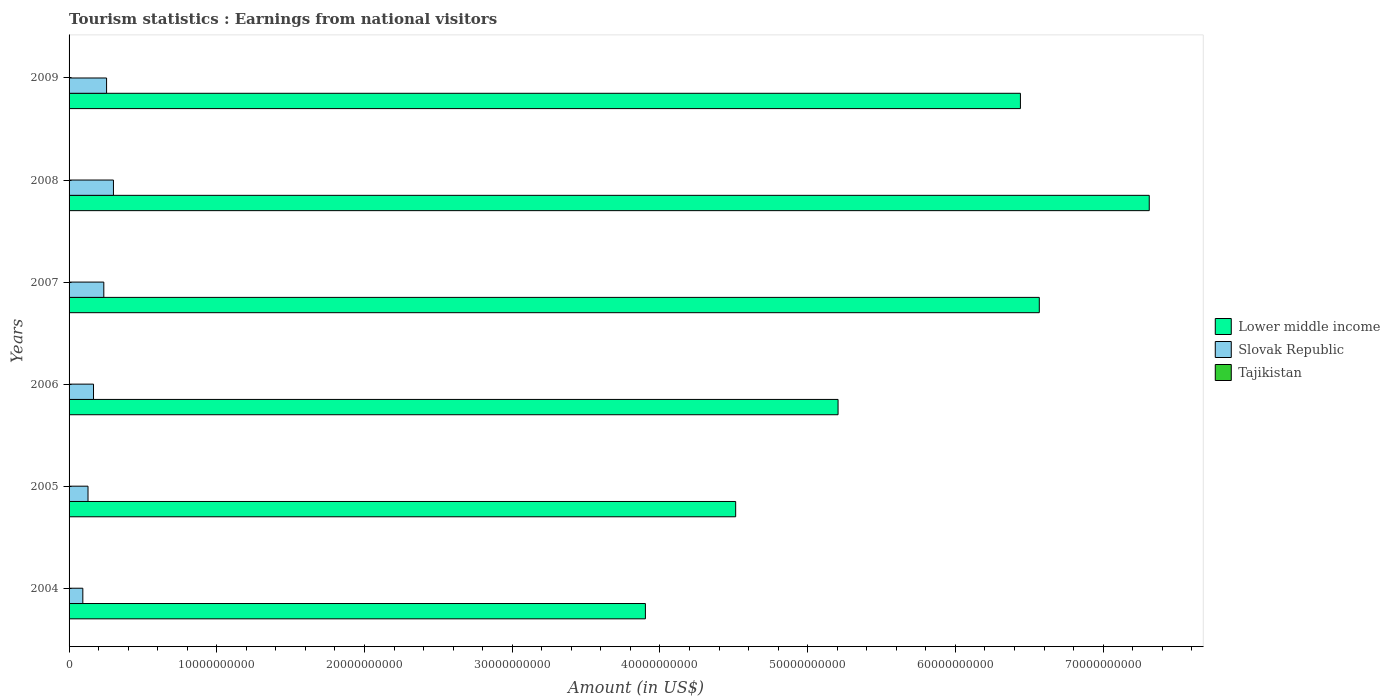How many different coloured bars are there?
Give a very brief answer. 3. How many groups of bars are there?
Provide a short and direct response. 6. Are the number of bars on each tick of the Y-axis equal?
Make the answer very short. Yes. How many bars are there on the 1st tick from the top?
Make the answer very short. 3. How many bars are there on the 2nd tick from the bottom?
Ensure brevity in your answer.  3. What is the label of the 4th group of bars from the top?
Make the answer very short. 2006. What is the earnings from national visitors in Tajikistan in 2009?
Your response must be concise. 1.95e+07. Across all years, what is the maximum earnings from national visitors in Lower middle income?
Provide a short and direct response. 7.31e+1. Across all years, what is the minimum earnings from national visitors in Tajikistan?
Offer a very short reply. 9.10e+06. In which year was the earnings from national visitors in Slovak Republic maximum?
Provide a short and direct response. 2008. What is the total earnings from national visitors in Tajikistan in the graph?
Ensure brevity in your answer.  8.96e+07. What is the difference between the earnings from national visitors in Lower middle income in 2004 and that in 2006?
Provide a short and direct response. -1.30e+1. What is the difference between the earnings from national visitors in Slovak Republic in 2009 and the earnings from national visitors in Tajikistan in 2007?
Provide a succinct answer. 2.52e+09. What is the average earnings from national visitors in Tajikistan per year?
Give a very brief answer. 1.49e+07. In the year 2008, what is the difference between the earnings from national visitors in Slovak Republic and earnings from national visitors in Lower middle income?
Make the answer very short. -7.01e+1. What is the ratio of the earnings from national visitors in Tajikistan in 2007 to that in 2009?
Provide a succinct answer. 0.85. What is the difference between the highest and the second highest earnings from national visitors in Lower middle income?
Provide a short and direct response. 7.44e+09. What is the difference between the highest and the lowest earnings from national visitors in Slovak Republic?
Provide a succinct answer. 2.07e+09. Is the sum of the earnings from national visitors in Lower middle income in 2005 and 2009 greater than the maximum earnings from national visitors in Tajikistan across all years?
Your answer should be compact. Yes. What does the 3rd bar from the top in 2005 represents?
Provide a succinct answer. Lower middle income. What does the 3rd bar from the bottom in 2007 represents?
Give a very brief answer. Tajikistan. Is it the case that in every year, the sum of the earnings from national visitors in Slovak Republic and earnings from national visitors in Lower middle income is greater than the earnings from national visitors in Tajikistan?
Make the answer very short. Yes. How many bars are there?
Ensure brevity in your answer.  18. What is the difference between two consecutive major ticks on the X-axis?
Your response must be concise. 1.00e+1. Are the values on the major ticks of X-axis written in scientific E-notation?
Your response must be concise. No. How many legend labels are there?
Your response must be concise. 3. How are the legend labels stacked?
Offer a terse response. Vertical. What is the title of the graph?
Offer a terse response. Tourism statistics : Earnings from national visitors. Does "Nigeria" appear as one of the legend labels in the graph?
Ensure brevity in your answer.  No. What is the Amount (in US$) in Lower middle income in 2004?
Ensure brevity in your answer.  3.90e+1. What is the Amount (in US$) of Slovak Republic in 2004?
Offer a terse response. 9.31e+08. What is the Amount (in US$) of Tajikistan in 2004?
Give a very brief answer. 9.60e+06. What is the Amount (in US$) in Lower middle income in 2005?
Make the answer very short. 4.51e+1. What is the Amount (in US$) of Slovak Republic in 2005?
Keep it short and to the point. 1.28e+09. What is the Amount (in US$) of Tajikistan in 2005?
Your answer should be very brief. 9.10e+06. What is the Amount (in US$) in Lower middle income in 2006?
Make the answer very short. 5.21e+1. What is the Amount (in US$) in Slovak Republic in 2006?
Your response must be concise. 1.66e+09. What is the Amount (in US$) of Tajikistan in 2006?
Your response must be concise. 1.12e+07. What is the Amount (in US$) of Lower middle income in 2007?
Ensure brevity in your answer.  6.57e+1. What is the Amount (in US$) in Slovak Republic in 2007?
Your answer should be compact. 2.35e+09. What is the Amount (in US$) in Tajikistan in 2007?
Keep it short and to the point. 1.65e+07. What is the Amount (in US$) of Lower middle income in 2008?
Keep it short and to the point. 7.31e+1. What is the Amount (in US$) of Slovak Republic in 2008?
Offer a terse response. 3.00e+09. What is the Amount (in US$) of Tajikistan in 2008?
Your response must be concise. 2.37e+07. What is the Amount (in US$) in Lower middle income in 2009?
Provide a short and direct response. 6.44e+1. What is the Amount (in US$) in Slovak Republic in 2009?
Give a very brief answer. 2.54e+09. What is the Amount (in US$) of Tajikistan in 2009?
Your response must be concise. 1.95e+07. Across all years, what is the maximum Amount (in US$) of Lower middle income?
Offer a very short reply. 7.31e+1. Across all years, what is the maximum Amount (in US$) of Slovak Republic?
Your response must be concise. 3.00e+09. Across all years, what is the maximum Amount (in US$) in Tajikistan?
Keep it short and to the point. 2.37e+07. Across all years, what is the minimum Amount (in US$) in Lower middle income?
Give a very brief answer. 3.90e+1. Across all years, what is the minimum Amount (in US$) of Slovak Republic?
Offer a very short reply. 9.31e+08. Across all years, what is the minimum Amount (in US$) in Tajikistan?
Give a very brief answer. 9.10e+06. What is the total Amount (in US$) of Lower middle income in the graph?
Your response must be concise. 3.39e+11. What is the total Amount (in US$) in Slovak Republic in the graph?
Provide a short and direct response. 1.18e+1. What is the total Amount (in US$) in Tajikistan in the graph?
Your response must be concise. 8.96e+07. What is the difference between the Amount (in US$) of Lower middle income in 2004 and that in 2005?
Offer a very short reply. -6.11e+09. What is the difference between the Amount (in US$) in Slovak Republic in 2004 and that in 2005?
Provide a succinct answer. -3.51e+08. What is the difference between the Amount (in US$) of Lower middle income in 2004 and that in 2006?
Offer a very short reply. -1.30e+1. What is the difference between the Amount (in US$) of Slovak Republic in 2004 and that in 2006?
Offer a very short reply. -7.24e+08. What is the difference between the Amount (in US$) of Tajikistan in 2004 and that in 2006?
Make the answer very short. -1.60e+06. What is the difference between the Amount (in US$) of Lower middle income in 2004 and that in 2007?
Keep it short and to the point. -2.67e+1. What is the difference between the Amount (in US$) in Slovak Republic in 2004 and that in 2007?
Your answer should be compact. -1.42e+09. What is the difference between the Amount (in US$) of Tajikistan in 2004 and that in 2007?
Your answer should be compact. -6.90e+06. What is the difference between the Amount (in US$) of Lower middle income in 2004 and that in 2008?
Ensure brevity in your answer.  -3.41e+1. What is the difference between the Amount (in US$) of Slovak Republic in 2004 and that in 2008?
Ensure brevity in your answer.  -2.07e+09. What is the difference between the Amount (in US$) of Tajikistan in 2004 and that in 2008?
Your answer should be very brief. -1.41e+07. What is the difference between the Amount (in US$) in Lower middle income in 2004 and that in 2009?
Make the answer very short. -2.54e+1. What is the difference between the Amount (in US$) of Slovak Republic in 2004 and that in 2009?
Offer a very short reply. -1.61e+09. What is the difference between the Amount (in US$) in Tajikistan in 2004 and that in 2009?
Keep it short and to the point. -9.90e+06. What is the difference between the Amount (in US$) in Lower middle income in 2005 and that in 2006?
Provide a succinct answer. -6.93e+09. What is the difference between the Amount (in US$) in Slovak Republic in 2005 and that in 2006?
Provide a short and direct response. -3.73e+08. What is the difference between the Amount (in US$) of Tajikistan in 2005 and that in 2006?
Keep it short and to the point. -2.10e+06. What is the difference between the Amount (in US$) in Lower middle income in 2005 and that in 2007?
Offer a terse response. -2.06e+1. What is the difference between the Amount (in US$) in Slovak Republic in 2005 and that in 2007?
Provide a short and direct response. -1.07e+09. What is the difference between the Amount (in US$) of Tajikistan in 2005 and that in 2007?
Offer a terse response. -7.40e+06. What is the difference between the Amount (in US$) of Lower middle income in 2005 and that in 2008?
Give a very brief answer. -2.80e+1. What is the difference between the Amount (in US$) in Slovak Republic in 2005 and that in 2008?
Offer a very short reply. -1.72e+09. What is the difference between the Amount (in US$) of Tajikistan in 2005 and that in 2008?
Ensure brevity in your answer.  -1.46e+07. What is the difference between the Amount (in US$) of Lower middle income in 2005 and that in 2009?
Offer a terse response. -1.93e+1. What is the difference between the Amount (in US$) in Slovak Republic in 2005 and that in 2009?
Offer a terse response. -1.26e+09. What is the difference between the Amount (in US$) in Tajikistan in 2005 and that in 2009?
Provide a succinct answer. -1.04e+07. What is the difference between the Amount (in US$) of Lower middle income in 2006 and that in 2007?
Provide a short and direct response. -1.36e+1. What is the difference between the Amount (in US$) of Slovak Republic in 2006 and that in 2007?
Offer a terse response. -6.97e+08. What is the difference between the Amount (in US$) in Tajikistan in 2006 and that in 2007?
Your answer should be very brief. -5.30e+06. What is the difference between the Amount (in US$) of Lower middle income in 2006 and that in 2008?
Make the answer very short. -2.11e+1. What is the difference between the Amount (in US$) in Slovak Republic in 2006 and that in 2008?
Offer a terse response. -1.35e+09. What is the difference between the Amount (in US$) of Tajikistan in 2006 and that in 2008?
Provide a short and direct response. -1.25e+07. What is the difference between the Amount (in US$) in Lower middle income in 2006 and that in 2009?
Your answer should be very brief. -1.23e+1. What is the difference between the Amount (in US$) in Slovak Republic in 2006 and that in 2009?
Provide a succinct answer. -8.84e+08. What is the difference between the Amount (in US$) in Tajikistan in 2006 and that in 2009?
Provide a succinct answer. -8.30e+06. What is the difference between the Amount (in US$) of Lower middle income in 2007 and that in 2008?
Give a very brief answer. -7.44e+09. What is the difference between the Amount (in US$) of Slovak Republic in 2007 and that in 2008?
Offer a very short reply. -6.52e+08. What is the difference between the Amount (in US$) of Tajikistan in 2007 and that in 2008?
Offer a very short reply. -7.20e+06. What is the difference between the Amount (in US$) in Lower middle income in 2007 and that in 2009?
Give a very brief answer. 1.28e+09. What is the difference between the Amount (in US$) in Slovak Republic in 2007 and that in 2009?
Make the answer very short. -1.87e+08. What is the difference between the Amount (in US$) in Lower middle income in 2008 and that in 2009?
Ensure brevity in your answer.  8.72e+09. What is the difference between the Amount (in US$) in Slovak Republic in 2008 and that in 2009?
Offer a terse response. 4.65e+08. What is the difference between the Amount (in US$) in Tajikistan in 2008 and that in 2009?
Your response must be concise. 4.20e+06. What is the difference between the Amount (in US$) in Lower middle income in 2004 and the Amount (in US$) in Slovak Republic in 2005?
Your answer should be very brief. 3.77e+1. What is the difference between the Amount (in US$) in Lower middle income in 2004 and the Amount (in US$) in Tajikistan in 2005?
Ensure brevity in your answer.  3.90e+1. What is the difference between the Amount (in US$) of Slovak Republic in 2004 and the Amount (in US$) of Tajikistan in 2005?
Give a very brief answer. 9.22e+08. What is the difference between the Amount (in US$) of Lower middle income in 2004 and the Amount (in US$) of Slovak Republic in 2006?
Ensure brevity in your answer.  3.74e+1. What is the difference between the Amount (in US$) of Lower middle income in 2004 and the Amount (in US$) of Tajikistan in 2006?
Provide a short and direct response. 3.90e+1. What is the difference between the Amount (in US$) in Slovak Republic in 2004 and the Amount (in US$) in Tajikistan in 2006?
Your answer should be compact. 9.20e+08. What is the difference between the Amount (in US$) in Lower middle income in 2004 and the Amount (in US$) in Slovak Republic in 2007?
Give a very brief answer. 3.67e+1. What is the difference between the Amount (in US$) in Lower middle income in 2004 and the Amount (in US$) in Tajikistan in 2007?
Your response must be concise. 3.90e+1. What is the difference between the Amount (in US$) in Slovak Republic in 2004 and the Amount (in US$) in Tajikistan in 2007?
Offer a very short reply. 9.14e+08. What is the difference between the Amount (in US$) in Lower middle income in 2004 and the Amount (in US$) in Slovak Republic in 2008?
Offer a terse response. 3.60e+1. What is the difference between the Amount (in US$) in Lower middle income in 2004 and the Amount (in US$) in Tajikistan in 2008?
Give a very brief answer. 3.90e+1. What is the difference between the Amount (in US$) of Slovak Republic in 2004 and the Amount (in US$) of Tajikistan in 2008?
Your answer should be compact. 9.07e+08. What is the difference between the Amount (in US$) in Lower middle income in 2004 and the Amount (in US$) in Slovak Republic in 2009?
Your answer should be very brief. 3.65e+1. What is the difference between the Amount (in US$) of Lower middle income in 2004 and the Amount (in US$) of Tajikistan in 2009?
Provide a short and direct response. 3.90e+1. What is the difference between the Amount (in US$) in Slovak Republic in 2004 and the Amount (in US$) in Tajikistan in 2009?
Provide a short and direct response. 9.12e+08. What is the difference between the Amount (in US$) of Lower middle income in 2005 and the Amount (in US$) of Slovak Republic in 2006?
Your answer should be very brief. 4.35e+1. What is the difference between the Amount (in US$) of Lower middle income in 2005 and the Amount (in US$) of Tajikistan in 2006?
Your answer should be very brief. 4.51e+1. What is the difference between the Amount (in US$) in Slovak Republic in 2005 and the Amount (in US$) in Tajikistan in 2006?
Your answer should be compact. 1.27e+09. What is the difference between the Amount (in US$) in Lower middle income in 2005 and the Amount (in US$) in Slovak Republic in 2007?
Make the answer very short. 4.28e+1. What is the difference between the Amount (in US$) in Lower middle income in 2005 and the Amount (in US$) in Tajikistan in 2007?
Provide a succinct answer. 4.51e+1. What is the difference between the Amount (in US$) in Slovak Republic in 2005 and the Amount (in US$) in Tajikistan in 2007?
Your answer should be very brief. 1.27e+09. What is the difference between the Amount (in US$) in Lower middle income in 2005 and the Amount (in US$) in Slovak Republic in 2008?
Ensure brevity in your answer.  4.21e+1. What is the difference between the Amount (in US$) of Lower middle income in 2005 and the Amount (in US$) of Tajikistan in 2008?
Offer a terse response. 4.51e+1. What is the difference between the Amount (in US$) in Slovak Republic in 2005 and the Amount (in US$) in Tajikistan in 2008?
Keep it short and to the point. 1.26e+09. What is the difference between the Amount (in US$) of Lower middle income in 2005 and the Amount (in US$) of Slovak Republic in 2009?
Provide a short and direct response. 4.26e+1. What is the difference between the Amount (in US$) of Lower middle income in 2005 and the Amount (in US$) of Tajikistan in 2009?
Make the answer very short. 4.51e+1. What is the difference between the Amount (in US$) in Slovak Republic in 2005 and the Amount (in US$) in Tajikistan in 2009?
Your answer should be compact. 1.26e+09. What is the difference between the Amount (in US$) of Lower middle income in 2006 and the Amount (in US$) of Slovak Republic in 2007?
Give a very brief answer. 4.97e+1. What is the difference between the Amount (in US$) of Lower middle income in 2006 and the Amount (in US$) of Tajikistan in 2007?
Provide a succinct answer. 5.20e+1. What is the difference between the Amount (in US$) in Slovak Republic in 2006 and the Amount (in US$) in Tajikistan in 2007?
Make the answer very short. 1.64e+09. What is the difference between the Amount (in US$) in Lower middle income in 2006 and the Amount (in US$) in Slovak Republic in 2008?
Offer a very short reply. 4.91e+1. What is the difference between the Amount (in US$) of Lower middle income in 2006 and the Amount (in US$) of Tajikistan in 2008?
Your answer should be compact. 5.20e+1. What is the difference between the Amount (in US$) in Slovak Republic in 2006 and the Amount (in US$) in Tajikistan in 2008?
Provide a succinct answer. 1.63e+09. What is the difference between the Amount (in US$) of Lower middle income in 2006 and the Amount (in US$) of Slovak Republic in 2009?
Offer a very short reply. 4.95e+1. What is the difference between the Amount (in US$) in Lower middle income in 2006 and the Amount (in US$) in Tajikistan in 2009?
Give a very brief answer. 5.20e+1. What is the difference between the Amount (in US$) of Slovak Republic in 2006 and the Amount (in US$) of Tajikistan in 2009?
Provide a succinct answer. 1.64e+09. What is the difference between the Amount (in US$) in Lower middle income in 2007 and the Amount (in US$) in Slovak Republic in 2008?
Give a very brief answer. 6.27e+1. What is the difference between the Amount (in US$) of Lower middle income in 2007 and the Amount (in US$) of Tajikistan in 2008?
Your response must be concise. 6.57e+1. What is the difference between the Amount (in US$) of Slovak Republic in 2007 and the Amount (in US$) of Tajikistan in 2008?
Give a very brief answer. 2.33e+09. What is the difference between the Amount (in US$) in Lower middle income in 2007 and the Amount (in US$) in Slovak Republic in 2009?
Offer a terse response. 6.31e+1. What is the difference between the Amount (in US$) in Lower middle income in 2007 and the Amount (in US$) in Tajikistan in 2009?
Offer a very short reply. 6.57e+1. What is the difference between the Amount (in US$) of Slovak Republic in 2007 and the Amount (in US$) of Tajikistan in 2009?
Keep it short and to the point. 2.33e+09. What is the difference between the Amount (in US$) in Lower middle income in 2008 and the Amount (in US$) in Slovak Republic in 2009?
Give a very brief answer. 7.06e+1. What is the difference between the Amount (in US$) of Lower middle income in 2008 and the Amount (in US$) of Tajikistan in 2009?
Provide a short and direct response. 7.31e+1. What is the difference between the Amount (in US$) of Slovak Republic in 2008 and the Amount (in US$) of Tajikistan in 2009?
Offer a terse response. 2.98e+09. What is the average Amount (in US$) in Lower middle income per year?
Your response must be concise. 5.66e+1. What is the average Amount (in US$) in Slovak Republic per year?
Give a very brief answer. 1.96e+09. What is the average Amount (in US$) of Tajikistan per year?
Provide a succinct answer. 1.49e+07. In the year 2004, what is the difference between the Amount (in US$) of Lower middle income and Amount (in US$) of Slovak Republic?
Offer a terse response. 3.81e+1. In the year 2004, what is the difference between the Amount (in US$) of Lower middle income and Amount (in US$) of Tajikistan?
Offer a very short reply. 3.90e+1. In the year 2004, what is the difference between the Amount (in US$) in Slovak Republic and Amount (in US$) in Tajikistan?
Provide a succinct answer. 9.21e+08. In the year 2005, what is the difference between the Amount (in US$) in Lower middle income and Amount (in US$) in Slovak Republic?
Make the answer very short. 4.38e+1. In the year 2005, what is the difference between the Amount (in US$) in Lower middle income and Amount (in US$) in Tajikistan?
Your answer should be compact. 4.51e+1. In the year 2005, what is the difference between the Amount (in US$) in Slovak Republic and Amount (in US$) in Tajikistan?
Provide a short and direct response. 1.27e+09. In the year 2006, what is the difference between the Amount (in US$) of Lower middle income and Amount (in US$) of Slovak Republic?
Your response must be concise. 5.04e+1. In the year 2006, what is the difference between the Amount (in US$) of Lower middle income and Amount (in US$) of Tajikistan?
Give a very brief answer. 5.20e+1. In the year 2006, what is the difference between the Amount (in US$) of Slovak Republic and Amount (in US$) of Tajikistan?
Your response must be concise. 1.64e+09. In the year 2007, what is the difference between the Amount (in US$) in Lower middle income and Amount (in US$) in Slovak Republic?
Ensure brevity in your answer.  6.33e+1. In the year 2007, what is the difference between the Amount (in US$) of Lower middle income and Amount (in US$) of Tajikistan?
Offer a terse response. 6.57e+1. In the year 2007, what is the difference between the Amount (in US$) of Slovak Republic and Amount (in US$) of Tajikistan?
Keep it short and to the point. 2.34e+09. In the year 2008, what is the difference between the Amount (in US$) of Lower middle income and Amount (in US$) of Slovak Republic?
Your answer should be compact. 7.01e+1. In the year 2008, what is the difference between the Amount (in US$) of Lower middle income and Amount (in US$) of Tajikistan?
Keep it short and to the point. 7.31e+1. In the year 2008, what is the difference between the Amount (in US$) in Slovak Republic and Amount (in US$) in Tajikistan?
Provide a short and direct response. 2.98e+09. In the year 2009, what is the difference between the Amount (in US$) of Lower middle income and Amount (in US$) of Slovak Republic?
Keep it short and to the point. 6.19e+1. In the year 2009, what is the difference between the Amount (in US$) in Lower middle income and Amount (in US$) in Tajikistan?
Offer a terse response. 6.44e+1. In the year 2009, what is the difference between the Amount (in US$) of Slovak Republic and Amount (in US$) of Tajikistan?
Make the answer very short. 2.52e+09. What is the ratio of the Amount (in US$) of Lower middle income in 2004 to that in 2005?
Offer a very short reply. 0.86. What is the ratio of the Amount (in US$) of Slovak Republic in 2004 to that in 2005?
Make the answer very short. 0.73. What is the ratio of the Amount (in US$) in Tajikistan in 2004 to that in 2005?
Provide a short and direct response. 1.05. What is the ratio of the Amount (in US$) in Lower middle income in 2004 to that in 2006?
Offer a terse response. 0.75. What is the ratio of the Amount (in US$) in Slovak Republic in 2004 to that in 2006?
Ensure brevity in your answer.  0.56. What is the ratio of the Amount (in US$) of Lower middle income in 2004 to that in 2007?
Offer a very short reply. 0.59. What is the ratio of the Amount (in US$) of Slovak Republic in 2004 to that in 2007?
Make the answer very short. 0.4. What is the ratio of the Amount (in US$) in Tajikistan in 2004 to that in 2007?
Ensure brevity in your answer.  0.58. What is the ratio of the Amount (in US$) of Lower middle income in 2004 to that in 2008?
Provide a short and direct response. 0.53. What is the ratio of the Amount (in US$) of Slovak Republic in 2004 to that in 2008?
Provide a succinct answer. 0.31. What is the ratio of the Amount (in US$) in Tajikistan in 2004 to that in 2008?
Provide a succinct answer. 0.41. What is the ratio of the Amount (in US$) in Lower middle income in 2004 to that in 2009?
Provide a short and direct response. 0.61. What is the ratio of the Amount (in US$) in Slovak Republic in 2004 to that in 2009?
Ensure brevity in your answer.  0.37. What is the ratio of the Amount (in US$) in Tajikistan in 2004 to that in 2009?
Offer a very short reply. 0.49. What is the ratio of the Amount (in US$) of Lower middle income in 2005 to that in 2006?
Keep it short and to the point. 0.87. What is the ratio of the Amount (in US$) of Slovak Republic in 2005 to that in 2006?
Give a very brief answer. 0.77. What is the ratio of the Amount (in US$) of Tajikistan in 2005 to that in 2006?
Give a very brief answer. 0.81. What is the ratio of the Amount (in US$) in Lower middle income in 2005 to that in 2007?
Give a very brief answer. 0.69. What is the ratio of the Amount (in US$) of Slovak Republic in 2005 to that in 2007?
Provide a succinct answer. 0.55. What is the ratio of the Amount (in US$) of Tajikistan in 2005 to that in 2007?
Offer a very short reply. 0.55. What is the ratio of the Amount (in US$) of Lower middle income in 2005 to that in 2008?
Your answer should be very brief. 0.62. What is the ratio of the Amount (in US$) of Slovak Republic in 2005 to that in 2008?
Offer a very short reply. 0.43. What is the ratio of the Amount (in US$) of Tajikistan in 2005 to that in 2008?
Give a very brief answer. 0.38. What is the ratio of the Amount (in US$) of Lower middle income in 2005 to that in 2009?
Keep it short and to the point. 0.7. What is the ratio of the Amount (in US$) in Slovak Republic in 2005 to that in 2009?
Make the answer very short. 0.5. What is the ratio of the Amount (in US$) in Tajikistan in 2005 to that in 2009?
Your answer should be very brief. 0.47. What is the ratio of the Amount (in US$) in Lower middle income in 2006 to that in 2007?
Your answer should be very brief. 0.79. What is the ratio of the Amount (in US$) in Slovak Republic in 2006 to that in 2007?
Provide a short and direct response. 0.7. What is the ratio of the Amount (in US$) of Tajikistan in 2006 to that in 2007?
Provide a short and direct response. 0.68. What is the ratio of the Amount (in US$) of Lower middle income in 2006 to that in 2008?
Your answer should be compact. 0.71. What is the ratio of the Amount (in US$) in Slovak Republic in 2006 to that in 2008?
Make the answer very short. 0.55. What is the ratio of the Amount (in US$) of Tajikistan in 2006 to that in 2008?
Offer a terse response. 0.47. What is the ratio of the Amount (in US$) of Lower middle income in 2006 to that in 2009?
Provide a short and direct response. 0.81. What is the ratio of the Amount (in US$) in Slovak Republic in 2006 to that in 2009?
Your response must be concise. 0.65. What is the ratio of the Amount (in US$) of Tajikistan in 2006 to that in 2009?
Keep it short and to the point. 0.57. What is the ratio of the Amount (in US$) of Lower middle income in 2007 to that in 2008?
Offer a very short reply. 0.9. What is the ratio of the Amount (in US$) in Slovak Republic in 2007 to that in 2008?
Your response must be concise. 0.78. What is the ratio of the Amount (in US$) of Tajikistan in 2007 to that in 2008?
Your answer should be very brief. 0.7. What is the ratio of the Amount (in US$) of Lower middle income in 2007 to that in 2009?
Make the answer very short. 1.02. What is the ratio of the Amount (in US$) in Slovak Republic in 2007 to that in 2009?
Provide a short and direct response. 0.93. What is the ratio of the Amount (in US$) of Tajikistan in 2007 to that in 2009?
Give a very brief answer. 0.85. What is the ratio of the Amount (in US$) in Lower middle income in 2008 to that in 2009?
Your answer should be compact. 1.14. What is the ratio of the Amount (in US$) of Slovak Republic in 2008 to that in 2009?
Your answer should be very brief. 1.18. What is the ratio of the Amount (in US$) in Tajikistan in 2008 to that in 2009?
Your response must be concise. 1.22. What is the difference between the highest and the second highest Amount (in US$) of Lower middle income?
Your answer should be very brief. 7.44e+09. What is the difference between the highest and the second highest Amount (in US$) of Slovak Republic?
Ensure brevity in your answer.  4.65e+08. What is the difference between the highest and the second highest Amount (in US$) of Tajikistan?
Offer a very short reply. 4.20e+06. What is the difference between the highest and the lowest Amount (in US$) of Lower middle income?
Give a very brief answer. 3.41e+1. What is the difference between the highest and the lowest Amount (in US$) of Slovak Republic?
Make the answer very short. 2.07e+09. What is the difference between the highest and the lowest Amount (in US$) of Tajikistan?
Ensure brevity in your answer.  1.46e+07. 